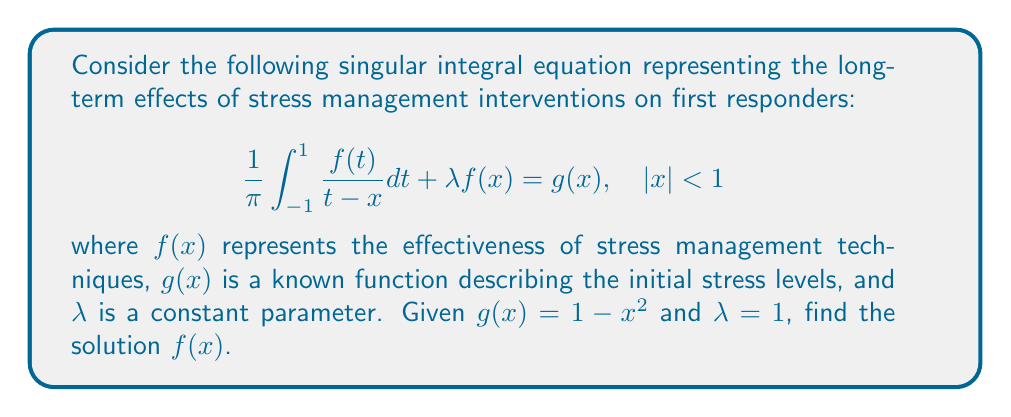Teach me how to tackle this problem. To solve this singular integral equation, we'll follow these steps:

1) This equation is a Cauchy-type singular integral equation. For such equations with $|x| < 1$, the solution can be expressed as:

   $$f(x) = \frac{A}{\sqrt{1-x^2}} + \frac{\sqrt{1-x^2}}{\pi} \int_{-1}^{1} \frac{g(t)}{(t-x)\sqrt{1-t^2}} dt$$

   where $A$ is a constant to be determined.

2) Substitute $g(x) = 1 - x^2$ into this general solution:

   $$f(x) = \frac{A}{\sqrt{1-x^2}} + \frac{\sqrt{1-x^2}}{\pi} \int_{-1}^{1} \frac{1-t^2}{(t-x)\sqrt{1-t^2}} dt$$

3) The integral can be evaluated using contour integration techniques:

   $$\int_{-1}^{1} \frac{1-t^2}{(t-x)\sqrt{1-t^2}} dt = \pi(1-x^2)$$

4) Substituting this result back into the equation:

   $$f(x) = \frac{A}{\sqrt{1-x^2}} + \sqrt{1-x^2}(1-x^2)$$

5) To determine $A$, we use the condition that $f(x)$ must be bounded at $x = \pm 1$. This is only possible if $A = 0$.

6) Therefore, the final solution is:

   $$f(x) = \sqrt{1-x^2}(1-x^2)$$

This solution represents the effectiveness of stress management techniques for first responders over time, with $x$ representing a normalized time scale from -1 to 1.
Answer: $f(x) = \sqrt{1-x^2}(1-x^2)$ 